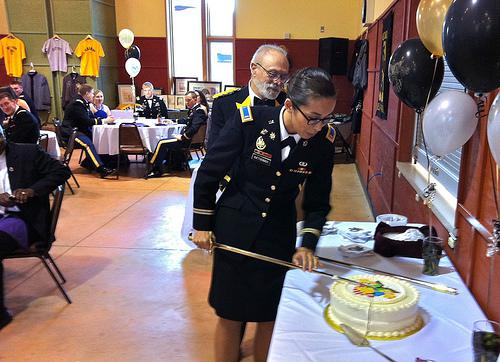Question: what is the lady doing?
Choices:
A. Dancing.
B. Singing.
C. Cutting a cake.
D. Smiling.
Answer with the letter. Answer: C Question: when was this photo taken?
Choices:
A. During the daytime.
B. At night.
C. During a football game.
D. At dusk.
Answer with the letter. Answer: A Question: how many black balloons are in the picture?
Choices:
A. Four.
B. Three.
C. Five.
D. Six.
Answer with the letter. Answer: B Question: who is cutting the cake?
Choices:
A. A man.
B. A girl.
C. A lady.
D. A boy.
Answer with the letter. Answer: C Question: what is the cake cutting lady wearing?
Choices:
A. A wedding dress.
B. A formal uniform.
C. A blue shirt.
D. Red pants.
Answer with the letter. Answer: B Question: where are the people sitting?
Choices:
A. On a bench.
B. Around the campfire.
C. At round tables.
D. At the theater.
Answer with the letter. Answer: C 